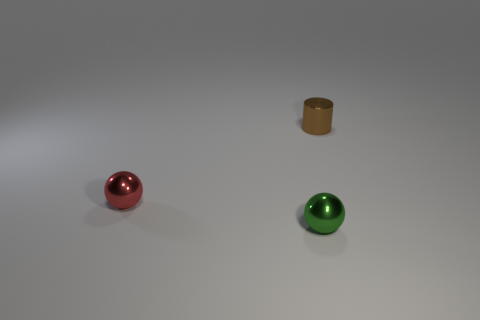Add 2 small shiny cylinders. How many objects exist? 5 Subtract all cylinders. How many objects are left? 2 Subtract all big brown rubber spheres. Subtract all small green metallic balls. How many objects are left? 2 Add 2 small red metallic spheres. How many small red metallic spheres are left? 3 Add 1 tiny red metallic balls. How many tiny red metallic balls exist? 2 Subtract 0 purple blocks. How many objects are left? 3 